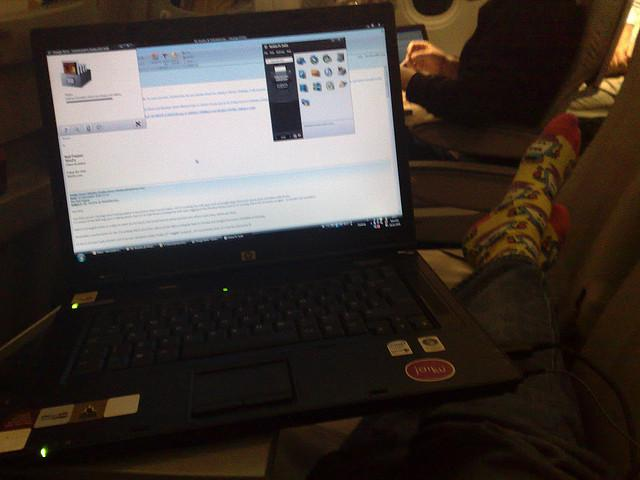This person is operating their laptop in what form of transportation?

Choices:
A) bus
B) train
C) plane
D) car plane 